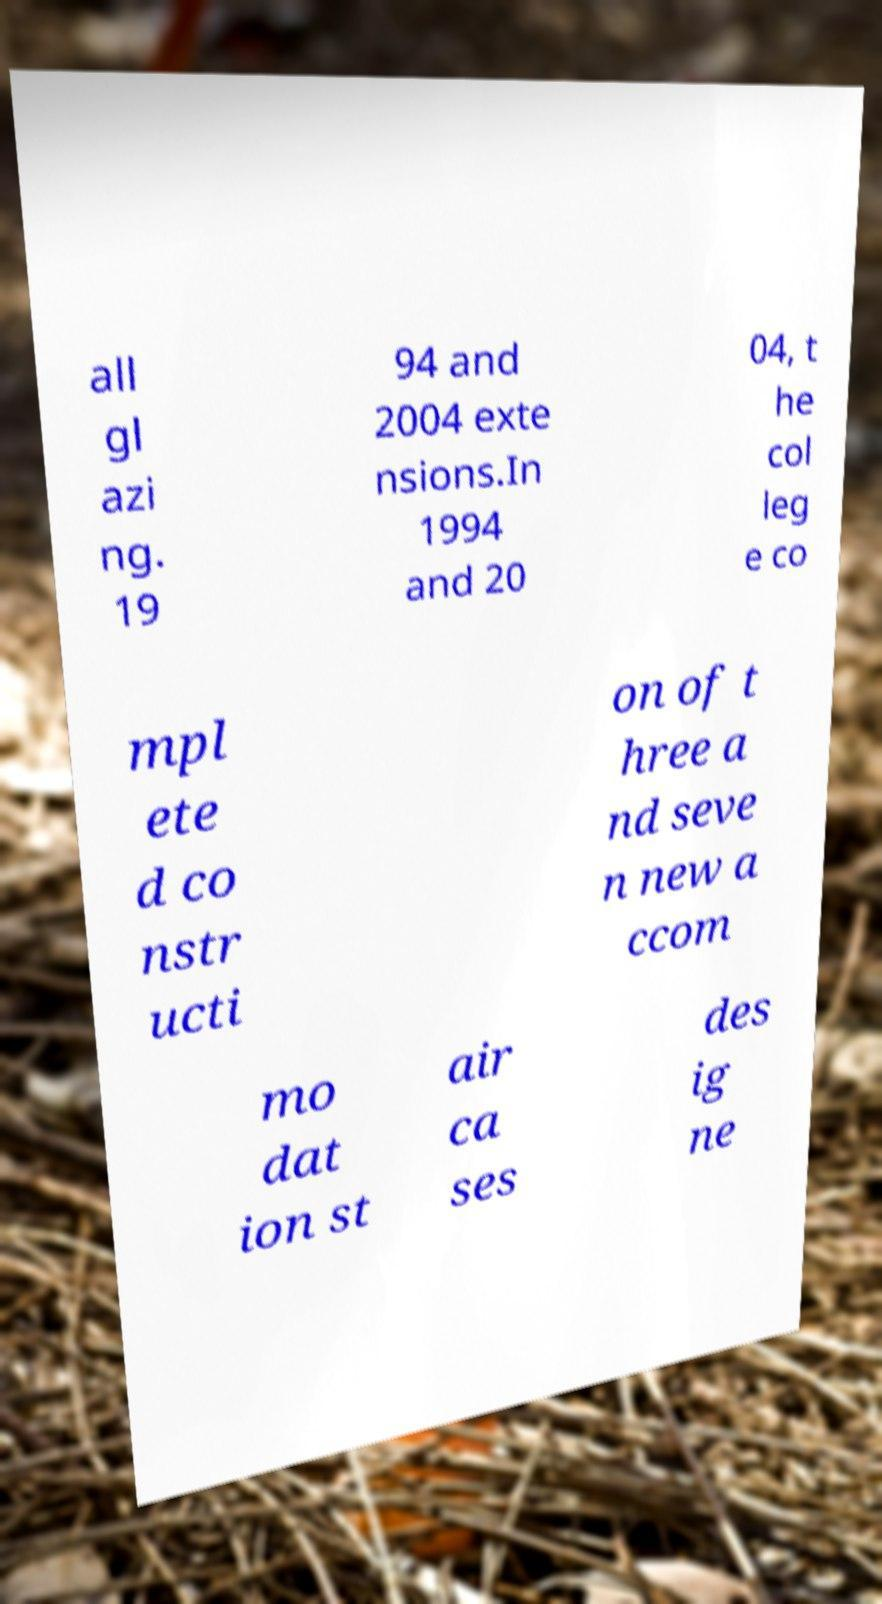Can you accurately transcribe the text from the provided image for me? all gl azi ng. 19 94 and 2004 exte nsions.In 1994 and 20 04, t he col leg e co mpl ete d co nstr ucti on of t hree a nd seve n new a ccom mo dat ion st air ca ses des ig ne 